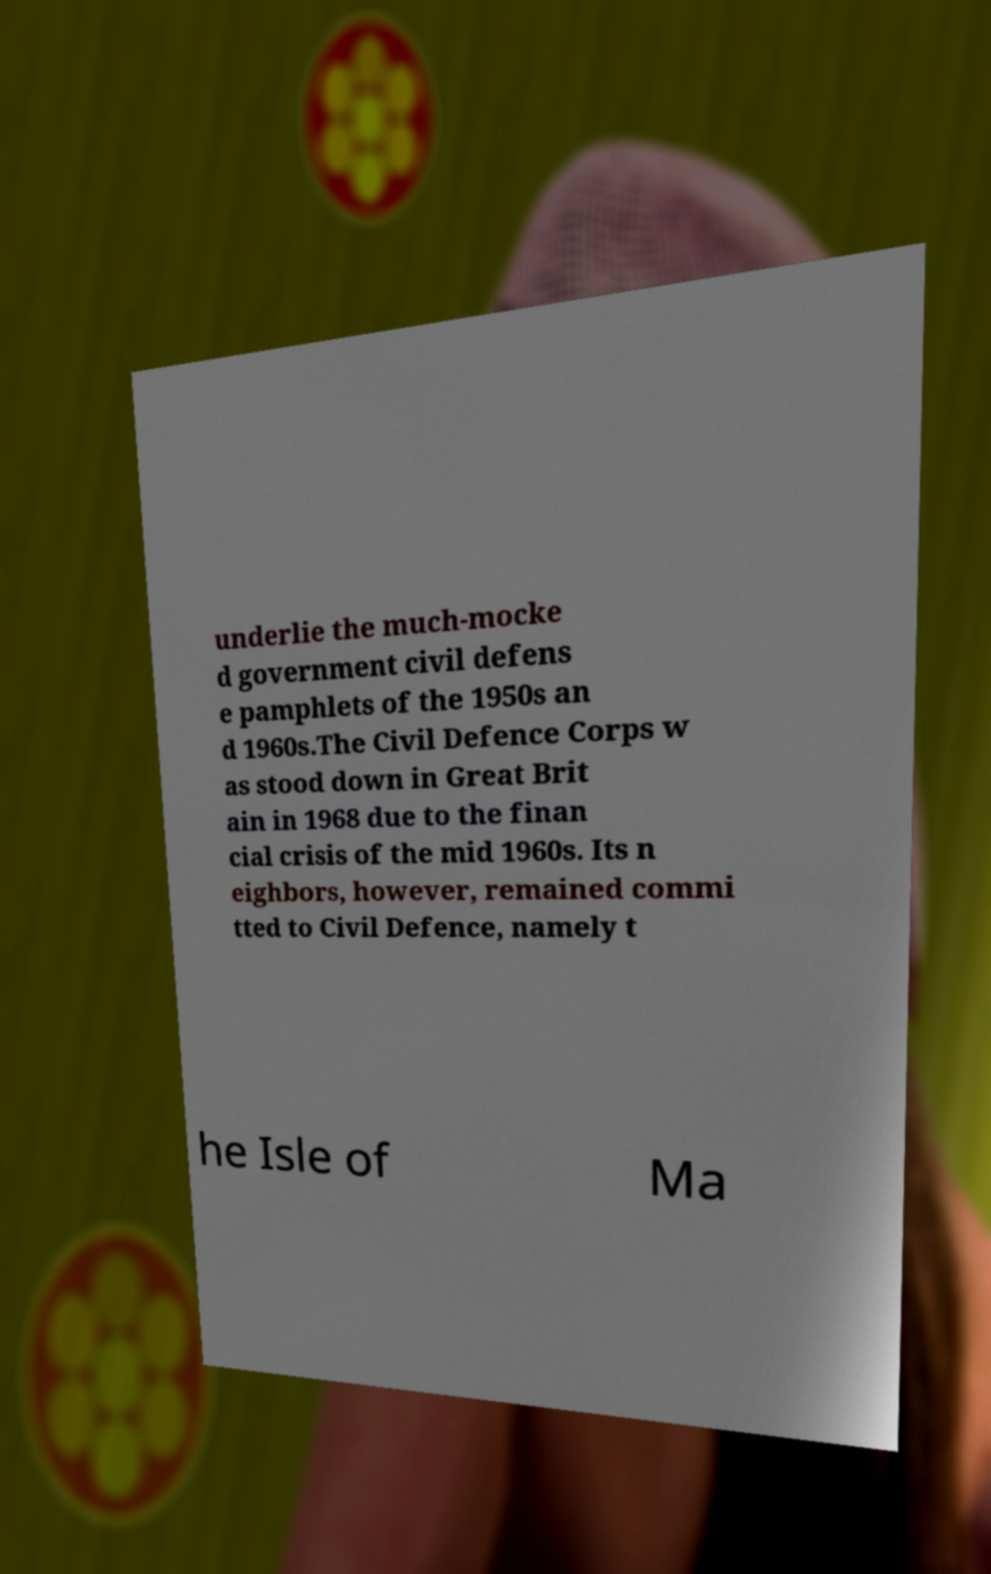For documentation purposes, I need the text within this image transcribed. Could you provide that? underlie the much-mocke d government civil defens e pamphlets of the 1950s an d 1960s.The Civil Defence Corps w as stood down in Great Brit ain in 1968 due to the finan cial crisis of the mid 1960s. Its n eighbors, however, remained commi tted to Civil Defence, namely t he Isle of Ma 